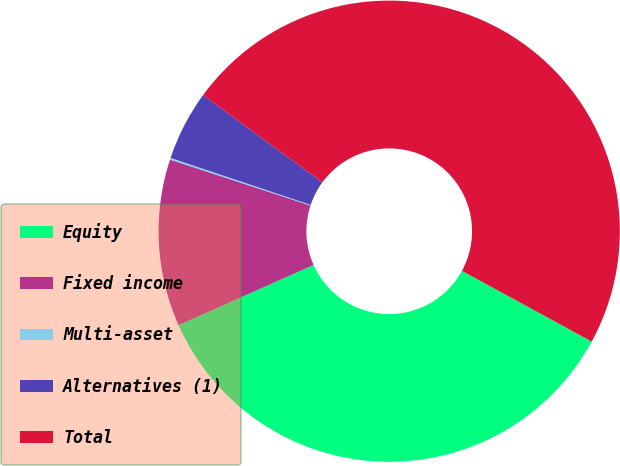<chart> <loc_0><loc_0><loc_500><loc_500><pie_chart><fcel>Equity<fcel>Fixed income<fcel>Multi-asset<fcel>Alternatives (1)<fcel>Total<nl><fcel>35.38%<fcel>11.71%<fcel>0.12%<fcel>4.9%<fcel>47.9%<nl></chart> 